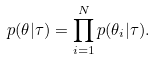<formula> <loc_0><loc_0><loc_500><loc_500>p ( \theta | \tau ) = \prod _ { i = 1 } ^ { N } p ( \theta _ { i } | \tau ) .</formula> 